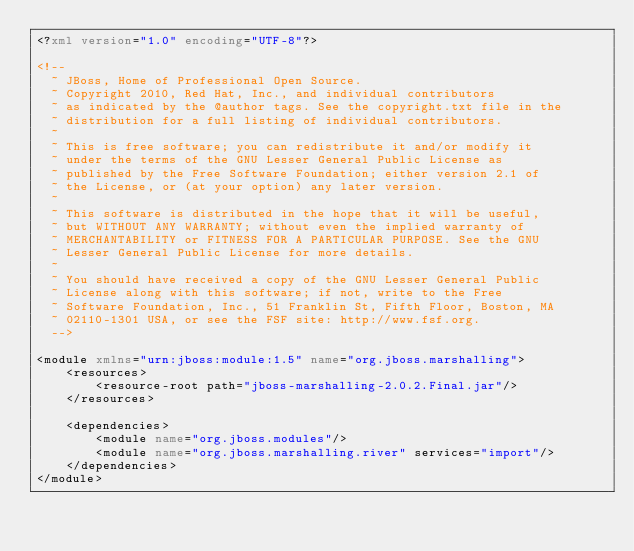<code> <loc_0><loc_0><loc_500><loc_500><_XML_><?xml version="1.0" encoding="UTF-8"?>

<!--
  ~ JBoss, Home of Professional Open Source.
  ~ Copyright 2010, Red Hat, Inc., and individual contributors
  ~ as indicated by the @author tags. See the copyright.txt file in the
  ~ distribution for a full listing of individual contributors.
  ~
  ~ This is free software; you can redistribute it and/or modify it
  ~ under the terms of the GNU Lesser General Public License as
  ~ published by the Free Software Foundation; either version 2.1 of
  ~ the License, or (at your option) any later version.
  ~
  ~ This software is distributed in the hope that it will be useful,
  ~ but WITHOUT ANY WARRANTY; without even the implied warranty of
  ~ MERCHANTABILITY or FITNESS FOR A PARTICULAR PURPOSE. See the GNU
  ~ Lesser General Public License for more details.
  ~
  ~ You should have received a copy of the GNU Lesser General Public
  ~ License along with this software; if not, write to the Free
  ~ Software Foundation, Inc., 51 Franklin St, Fifth Floor, Boston, MA
  ~ 02110-1301 USA, or see the FSF site: http://www.fsf.org.
  -->

<module xmlns="urn:jboss:module:1.5" name="org.jboss.marshalling">
    <resources>
        <resource-root path="jboss-marshalling-2.0.2.Final.jar"/>
    </resources>

    <dependencies>
        <module name="org.jboss.modules"/>
        <module name="org.jboss.marshalling.river" services="import"/>
    </dependencies>
</module>
</code> 